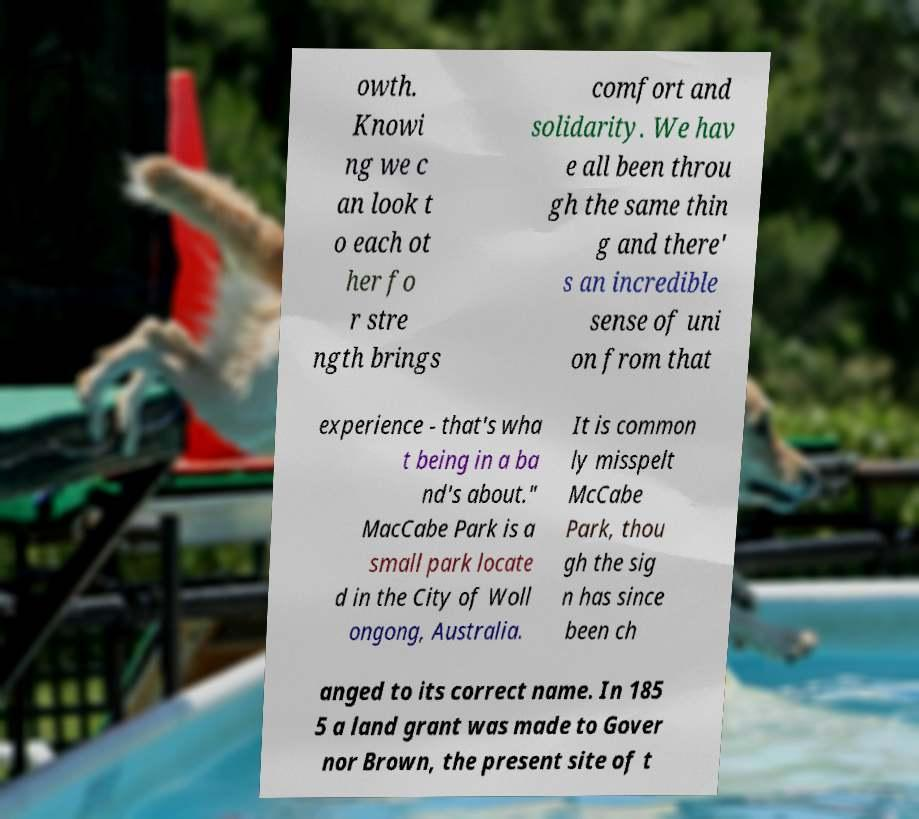Could you assist in decoding the text presented in this image and type it out clearly? owth. Knowi ng we c an look t o each ot her fo r stre ngth brings comfort and solidarity. We hav e all been throu gh the same thin g and there' s an incredible sense of uni on from that experience - that's wha t being in a ba nd's about." MacCabe Park is a small park locate d in the City of Woll ongong, Australia. It is common ly misspelt McCabe Park, thou gh the sig n has since been ch anged to its correct name. In 185 5 a land grant was made to Gover nor Brown, the present site of t 